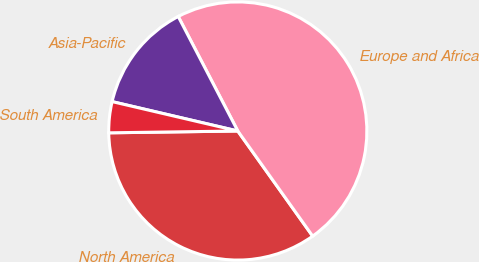Convert chart to OTSL. <chart><loc_0><loc_0><loc_500><loc_500><pie_chart><fcel>North America<fcel>Europe and Africa<fcel>Asia-Pacific<fcel>South America<nl><fcel>34.63%<fcel>47.79%<fcel>13.71%<fcel>3.88%<nl></chart> 